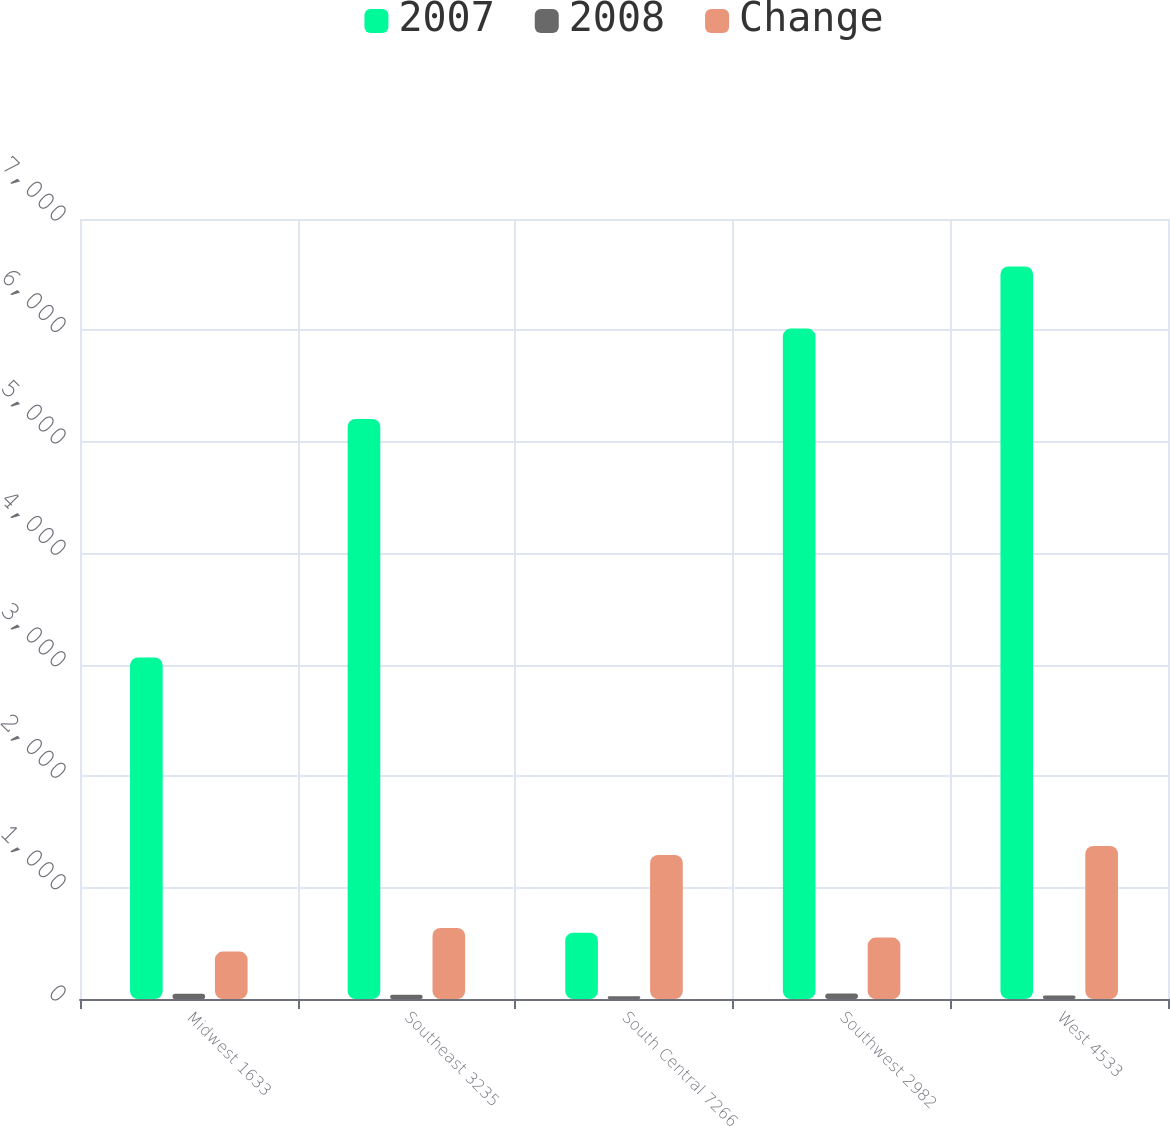Convert chart. <chart><loc_0><loc_0><loc_500><loc_500><stacked_bar_chart><ecel><fcel>Midwest 1633<fcel>Southeast 3235<fcel>South Central 7266<fcel>Southwest 2982<fcel>West 4533<nl><fcel>2007<fcel>3065<fcel>5206<fcel>594.6<fcel>6017<fcel>6574<nl><fcel>2008<fcel>47<fcel>38<fcel>25<fcel>50<fcel>31<nl><fcel>Change<fcel>425.3<fcel>637.6<fcel>1293.3<fcel>551.6<fcel>1373.1<nl></chart> 